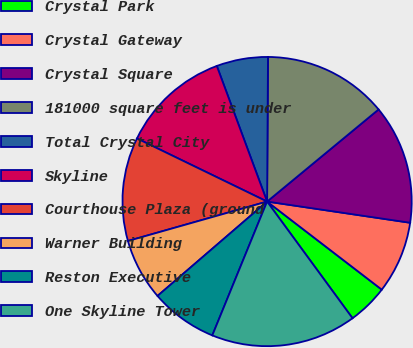Convert chart. <chart><loc_0><loc_0><loc_500><loc_500><pie_chart><fcel>Crystal Park<fcel>Crystal Gateway<fcel>Crystal Square<fcel>181000 square feet is under<fcel>Total Crystal City<fcel>Skyline<fcel>Courthouse Plaza (ground<fcel>Warner Building<fcel>Reston Executive<fcel>One Skyline Tower<nl><fcel>4.52%<fcel>8.08%<fcel>13.33%<fcel>13.91%<fcel>5.75%<fcel>12.16%<fcel>11.58%<fcel>6.92%<fcel>7.5%<fcel>16.24%<nl></chart> 